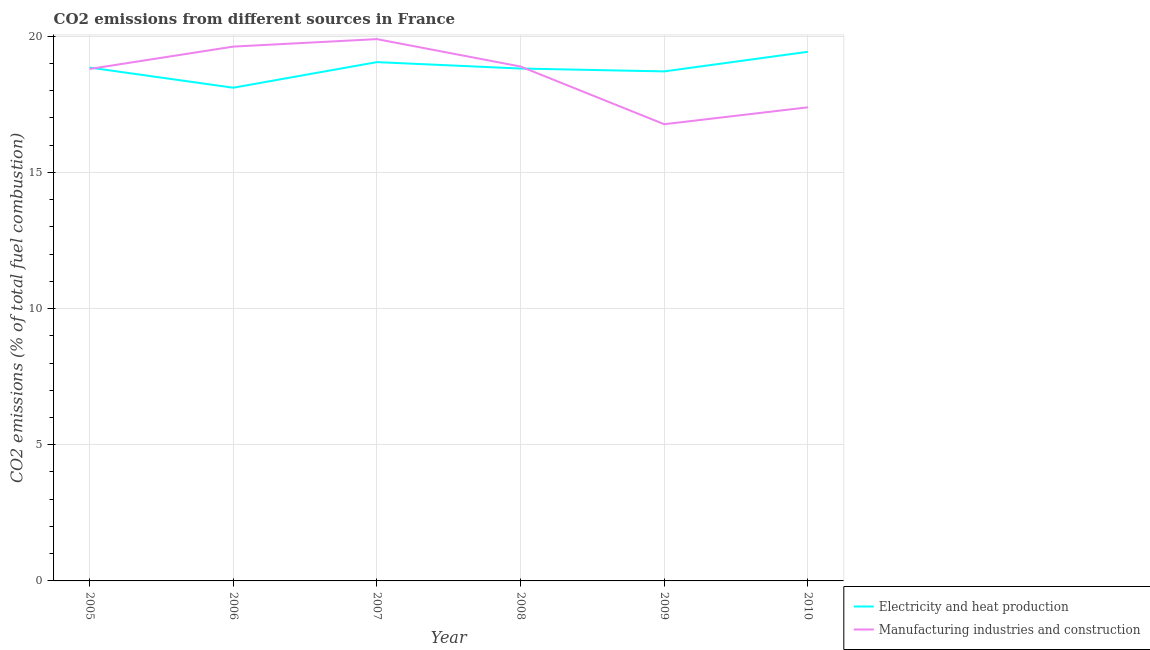Does the line corresponding to co2 emissions due to electricity and heat production intersect with the line corresponding to co2 emissions due to manufacturing industries?
Your answer should be compact. Yes. Is the number of lines equal to the number of legend labels?
Offer a terse response. Yes. What is the co2 emissions due to electricity and heat production in 2010?
Keep it short and to the point. 19.43. Across all years, what is the maximum co2 emissions due to manufacturing industries?
Your answer should be compact. 19.89. Across all years, what is the minimum co2 emissions due to electricity and heat production?
Make the answer very short. 18.11. In which year was the co2 emissions due to manufacturing industries maximum?
Ensure brevity in your answer.  2007. What is the total co2 emissions due to manufacturing industries in the graph?
Your response must be concise. 111.37. What is the difference between the co2 emissions due to manufacturing industries in 2005 and that in 2008?
Your answer should be very brief. -0.09. What is the difference between the co2 emissions due to manufacturing industries in 2006 and the co2 emissions due to electricity and heat production in 2005?
Keep it short and to the point. 0.77. What is the average co2 emissions due to manufacturing industries per year?
Provide a short and direct response. 18.56. In the year 2008, what is the difference between the co2 emissions due to electricity and heat production and co2 emissions due to manufacturing industries?
Your answer should be compact. -0.07. In how many years, is the co2 emissions due to electricity and heat production greater than 7 %?
Provide a short and direct response. 6. What is the ratio of the co2 emissions due to electricity and heat production in 2007 to that in 2009?
Offer a very short reply. 1.02. Is the co2 emissions due to electricity and heat production in 2007 less than that in 2008?
Your answer should be compact. No. Is the difference between the co2 emissions due to electricity and heat production in 2006 and 2008 greater than the difference between the co2 emissions due to manufacturing industries in 2006 and 2008?
Ensure brevity in your answer.  No. What is the difference between the highest and the second highest co2 emissions due to electricity and heat production?
Your answer should be very brief. 0.38. What is the difference between the highest and the lowest co2 emissions due to manufacturing industries?
Give a very brief answer. 3.12. Is the sum of the co2 emissions due to manufacturing industries in 2007 and 2009 greater than the maximum co2 emissions due to electricity and heat production across all years?
Give a very brief answer. Yes. Does the co2 emissions due to manufacturing industries monotonically increase over the years?
Offer a terse response. No. Is the co2 emissions due to manufacturing industries strictly less than the co2 emissions due to electricity and heat production over the years?
Give a very brief answer. No. How many years are there in the graph?
Offer a terse response. 6. What is the difference between two consecutive major ticks on the Y-axis?
Ensure brevity in your answer.  5. Are the values on the major ticks of Y-axis written in scientific E-notation?
Provide a succinct answer. No. How are the legend labels stacked?
Make the answer very short. Vertical. What is the title of the graph?
Give a very brief answer. CO2 emissions from different sources in France. What is the label or title of the X-axis?
Your answer should be compact. Year. What is the label or title of the Y-axis?
Offer a terse response. CO2 emissions (% of total fuel combustion). What is the CO2 emissions (% of total fuel combustion) in Electricity and heat production in 2005?
Ensure brevity in your answer.  18.85. What is the CO2 emissions (% of total fuel combustion) in Manufacturing industries and construction in 2005?
Your answer should be very brief. 18.8. What is the CO2 emissions (% of total fuel combustion) of Electricity and heat production in 2006?
Your answer should be compact. 18.11. What is the CO2 emissions (% of total fuel combustion) of Manufacturing industries and construction in 2006?
Make the answer very short. 19.62. What is the CO2 emissions (% of total fuel combustion) in Electricity and heat production in 2007?
Your answer should be compact. 19.05. What is the CO2 emissions (% of total fuel combustion) in Manufacturing industries and construction in 2007?
Your answer should be compact. 19.89. What is the CO2 emissions (% of total fuel combustion) in Electricity and heat production in 2008?
Your answer should be compact. 18.82. What is the CO2 emissions (% of total fuel combustion) in Manufacturing industries and construction in 2008?
Offer a very short reply. 18.89. What is the CO2 emissions (% of total fuel combustion) of Electricity and heat production in 2009?
Your response must be concise. 18.71. What is the CO2 emissions (% of total fuel combustion) of Manufacturing industries and construction in 2009?
Keep it short and to the point. 16.77. What is the CO2 emissions (% of total fuel combustion) of Electricity and heat production in 2010?
Your response must be concise. 19.43. What is the CO2 emissions (% of total fuel combustion) of Manufacturing industries and construction in 2010?
Make the answer very short. 17.39. Across all years, what is the maximum CO2 emissions (% of total fuel combustion) in Electricity and heat production?
Make the answer very short. 19.43. Across all years, what is the maximum CO2 emissions (% of total fuel combustion) in Manufacturing industries and construction?
Offer a terse response. 19.89. Across all years, what is the minimum CO2 emissions (% of total fuel combustion) in Electricity and heat production?
Give a very brief answer. 18.11. Across all years, what is the minimum CO2 emissions (% of total fuel combustion) of Manufacturing industries and construction?
Your response must be concise. 16.77. What is the total CO2 emissions (% of total fuel combustion) of Electricity and heat production in the graph?
Make the answer very short. 112.97. What is the total CO2 emissions (% of total fuel combustion) of Manufacturing industries and construction in the graph?
Provide a short and direct response. 111.37. What is the difference between the CO2 emissions (% of total fuel combustion) in Electricity and heat production in 2005 and that in 2006?
Your answer should be very brief. 0.74. What is the difference between the CO2 emissions (% of total fuel combustion) in Manufacturing industries and construction in 2005 and that in 2006?
Provide a short and direct response. -0.82. What is the difference between the CO2 emissions (% of total fuel combustion) of Electricity and heat production in 2005 and that in 2007?
Offer a terse response. -0.2. What is the difference between the CO2 emissions (% of total fuel combustion) in Manufacturing industries and construction in 2005 and that in 2007?
Your answer should be very brief. -1.1. What is the difference between the CO2 emissions (% of total fuel combustion) in Electricity and heat production in 2005 and that in 2008?
Keep it short and to the point. 0.04. What is the difference between the CO2 emissions (% of total fuel combustion) of Manufacturing industries and construction in 2005 and that in 2008?
Your response must be concise. -0.09. What is the difference between the CO2 emissions (% of total fuel combustion) in Electricity and heat production in 2005 and that in 2009?
Keep it short and to the point. 0.14. What is the difference between the CO2 emissions (% of total fuel combustion) of Manufacturing industries and construction in 2005 and that in 2009?
Provide a short and direct response. 2.03. What is the difference between the CO2 emissions (% of total fuel combustion) of Electricity and heat production in 2005 and that in 2010?
Your answer should be compact. -0.58. What is the difference between the CO2 emissions (% of total fuel combustion) in Manufacturing industries and construction in 2005 and that in 2010?
Keep it short and to the point. 1.41. What is the difference between the CO2 emissions (% of total fuel combustion) in Electricity and heat production in 2006 and that in 2007?
Ensure brevity in your answer.  -0.94. What is the difference between the CO2 emissions (% of total fuel combustion) in Manufacturing industries and construction in 2006 and that in 2007?
Provide a succinct answer. -0.27. What is the difference between the CO2 emissions (% of total fuel combustion) in Electricity and heat production in 2006 and that in 2008?
Your answer should be compact. -0.7. What is the difference between the CO2 emissions (% of total fuel combustion) of Manufacturing industries and construction in 2006 and that in 2008?
Offer a terse response. 0.73. What is the difference between the CO2 emissions (% of total fuel combustion) of Electricity and heat production in 2006 and that in 2009?
Provide a succinct answer. -0.6. What is the difference between the CO2 emissions (% of total fuel combustion) in Manufacturing industries and construction in 2006 and that in 2009?
Provide a succinct answer. 2.85. What is the difference between the CO2 emissions (% of total fuel combustion) of Electricity and heat production in 2006 and that in 2010?
Offer a very short reply. -1.32. What is the difference between the CO2 emissions (% of total fuel combustion) in Manufacturing industries and construction in 2006 and that in 2010?
Give a very brief answer. 2.23. What is the difference between the CO2 emissions (% of total fuel combustion) of Electricity and heat production in 2007 and that in 2008?
Your response must be concise. 0.24. What is the difference between the CO2 emissions (% of total fuel combustion) of Manufacturing industries and construction in 2007 and that in 2008?
Provide a short and direct response. 1.01. What is the difference between the CO2 emissions (% of total fuel combustion) of Electricity and heat production in 2007 and that in 2009?
Your answer should be compact. 0.34. What is the difference between the CO2 emissions (% of total fuel combustion) in Manufacturing industries and construction in 2007 and that in 2009?
Your answer should be compact. 3.12. What is the difference between the CO2 emissions (% of total fuel combustion) in Electricity and heat production in 2007 and that in 2010?
Your response must be concise. -0.38. What is the difference between the CO2 emissions (% of total fuel combustion) of Manufacturing industries and construction in 2007 and that in 2010?
Your answer should be compact. 2.5. What is the difference between the CO2 emissions (% of total fuel combustion) of Electricity and heat production in 2008 and that in 2009?
Offer a terse response. 0.11. What is the difference between the CO2 emissions (% of total fuel combustion) in Manufacturing industries and construction in 2008 and that in 2009?
Offer a very short reply. 2.12. What is the difference between the CO2 emissions (% of total fuel combustion) of Electricity and heat production in 2008 and that in 2010?
Keep it short and to the point. -0.61. What is the difference between the CO2 emissions (% of total fuel combustion) of Manufacturing industries and construction in 2008 and that in 2010?
Your answer should be compact. 1.5. What is the difference between the CO2 emissions (% of total fuel combustion) in Electricity and heat production in 2009 and that in 2010?
Offer a terse response. -0.72. What is the difference between the CO2 emissions (% of total fuel combustion) of Manufacturing industries and construction in 2009 and that in 2010?
Ensure brevity in your answer.  -0.62. What is the difference between the CO2 emissions (% of total fuel combustion) of Electricity and heat production in 2005 and the CO2 emissions (% of total fuel combustion) of Manufacturing industries and construction in 2006?
Offer a terse response. -0.77. What is the difference between the CO2 emissions (% of total fuel combustion) of Electricity and heat production in 2005 and the CO2 emissions (% of total fuel combustion) of Manufacturing industries and construction in 2007?
Ensure brevity in your answer.  -1.04. What is the difference between the CO2 emissions (% of total fuel combustion) of Electricity and heat production in 2005 and the CO2 emissions (% of total fuel combustion) of Manufacturing industries and construction in 2008?
Your response must be concise. -0.04. What is the difference between the CO2 emissions (% of total fuel combustion) of Electricity and heat production in 2005 and the CO2 emissions (% of total fuel combustion) of Manufacturing industries and construction in 2009?
Provide a short and direct response. 2.08. What is the difference between the CO2 emissions (% of total fuel combustion) in Electricity and heat production in 2005 and the CO2 emissions (% of total fuel combustion) in Manufacturing industries and construction in 2010?
Your answer should be very brief. 1.46. What is the difference between the CO2 emissions (% of total fuel combustion) of Electricity and heat production in 2006 and the CO2 emissions (% of total fuel combustion) of Manufacturing industries and construction in 2007?
Ensure brevity in your answer.  -1.78. What is the difference between the CO2 emissions (% of total fuel combustion) of Electricity and heat production in 2006 and the CO2 emissions (% of total fuel combustion) of Manufacturing industries and construction in 2008?
Provide a succinct answer. -0.78. What is the difference between the CO2 emissions (% of total fuel combustion) in Electricity and heat production in 2006 and the CO2 emissions (% of total fuel combustion) in Manufacturing industries and construction in 2009?
Offer a very short reply. 1.34. What is the difference between the CO2 emissions (% of total fuel combustion) of Electricity and heat production in 2006 and the CO2 emissions (% of total fuel combustion) of Manufacturing industries and construction in 2010?
Your response must be concise. 0.72. What is the difference between the CO2 emissions (% of total fuel combustion) of Electricity and heat production in 2007 and the CO2 emissions (% of total fuel combustion) of Manufacturing industries and construction in 2008?
Offer a very short reply. 0.16. What is the difference between the CO2 emissions (% of total fuel combustion) of Electricity and heat production in 2007 and the CO2 emissions (% of total fuel combustion) of Manufacturing industries and construction in 2009?
Your answer should be compact. 2.28. What is the difference between the CO2 emissions (% of total fuel combustion) in Electricity and heat production in 2007 and the CO2 emissions (% of total fuel combustion) in Manufacturing industries and construction in 2010?
Keep it short and to the point. 1.66. What is the difference between the CO2 emissions (% of total fuel combustion) in Electricity and heat production in 2008 and the CO2 emissions (% of total fuel combustion) in Manufacturing industries and construction in 2009?
Your response must be concise. 2.04. What is the difference between the CO2 emissions (% of total fuel combustion) of Electricity and heat production in 2008 and the CO2 emissions (% of total fuel combustion) of Manufacturing industries and construction in 2010?
Your answer should be very brief. 1.42. What is the difference between the CO2 emissions (% of total fuel combustion) in Electricity and heat production in 2009 and the CO2 emissions (% of total fuel combustion) in Manufacturing industries and construction in 2010?
Provide a succinct answer. 1.32. What is the average CO2 emissions (% of total fuel combustion) in Electricity and heat production per year?
Provide a succinct answer. 18.83. What is the average CO2 emissions (% of total fuel combustion) in Manufacturing industries and construction per year?
Give a very brief answer. 18.56. In the year 2005, what is the difference between the CO2 emissions (% of total fuel combustion) of Electricity and heat production and CO2 emissions (% of total fuel combustion) of Manufacturing industries and construction?
Offer a terse response. 0.05. In the year 2006, what is the difference between the CO2 emissions (% of total fuel combustion) in Electricity and heat production and CO2 emissions (% of total fuel combustion) in Manufacturing industries and construction?
Ensure brevity in your answer.  -1.51. In the year 2007, what is the difference between the CO2 emissions (% of total fuel combustion) of Electricity and heat production and CO2 emissions (% of total fuel combustion) of Manufacturing industries and construction?
Provide a succinct answer. -0.84. In the year 2008, what is the difference between the CO2 emissions (% of total fuel combustion) in Electricity and heat production and CO2 emissions (% of total fuel combustion) in Manufacturing industries and construction?
Your answer should be very brief. -0.07. In the year 2009, what is the difference between the CO2 emissions (% of total fuel combustion) in Electricity and heat production and CO2 emissions (% of total fuel combustion) in Manufacturing industries and construction?
Keep it short and to the point. 1.94. In the year 2010, what is the difference between the CO2 emissions (% of total fuel combustion) in Electricity and heat production and CO2 emissions (% of total fuel combustion) in Manufacturing industries and construction?
Your answer should be compact. 2.04. What is the ratio of the CO2 emissions (% of total fuel combustion) of Electricity and heat production in 2005 to that in 2006?
Make the answer very short. 1.04. What is the ratio of the CO2 emissions (% of total fuel combustion) in Manufacturing industries and construction in 2005 to that in 2006?
Offer a very short reply. 0.96. What is the ratio of the CO2 emissions (% of total fuel combustion) in Electricity and heat production in 2005 to that in 2007?
Make the answer very short. 0.99. What is the ratio of the CO2 emissions (% of total fuel combustion) in Manufacturing industries and construction in 2005 to that in 2007?
Your answer should be very brief. 0.94. What is the ratio of the CO2 emissions (% of total fuel combustion) of Manufacturing industries and construction in 2005 to that in 2008?
Provide a short and direct response. 1. What is the ratio of the CO2 emissions (% of total fuel combustion) of Electricity and heat production in 2005 to that in 2009?
Provide a short and direct response. 1.01. What is the ratio of the CO2 emissions (% of total fuel combustion) in Manufacturing industries and construction in 2005 to that in 2009?
Make the answer very short. 1.12. What is the ratio of the CO2 emissions (% of total fuel combustion) in Electricity and heat production in 2005 to that in 2010?
Offer a terse response. 0.97. What is the ratio of the CO2 emissions (% of total fuel combustion) of Manufacturing industries and construction in 2005 to that in 2010?
Ensure brevity in your answer.  1.08. What is the ratio of the CO2 emissions (% of total fuel combustion) of Electricity and heat production in 2006 to that in 2007?
Make the answer very short. 0.95. What is the ratio of the CO2 emissions (% of total fuel combustion) of Manufacturing industries and construction in 2006 to that in 2007?
Keep it short and to the point. 0.99. What is the ratio of the CO2 emissions (% of total fuel combustion) of Electricity and heat production in 2006 to that in 2008?
Ensure brevity in your answer.  0.96. What is the ratio of the CO2 emissions (% of total fuel combustion) of Manufacturing industries and construction in 2006 to that in 2008?
Your response must be concise. 1.04. What is the ratio of the CO2 emissions (% of total fuel combustion) in Electricity and heat production in 2006 to that in 2009?
Your answer should be compact. 0.97. What is the ratio of the CO2 emissions (% of total fuel combustion) of Manufacturing industries and construction in 2006 to that in 2009?
Offer a terse response. 1.17. What is the ratio of the CO2 emissions (% of total fuel combustion) of Electricity and heat production in 2006 to that in 2010?
Provide a succinct answer. 0.93. What is the ratio of the CO2 emissions (% of total fuel combustion) in Manufacturing industries and construction in 2006 to that in 2010?
Your answer should be compact. 1.13. What is the ratio of the CO2 emissions (% of total fuel combustion) of Electricity and heat production in 2007 to that in 2008?
Offer a very short reply. 1.01. What is the ratio of the CO2 emissions (% of total fuel combustion) in Manufacturing industries and construction in 2007 to that in 2008?
Make the answer very short. 1.05. What is the ratio of the CO2 emissions (% of total fuel combustion) of Electricity and heat production in 2007 to that in 2009?
Ensure brevity in your answer.  1.02. What is the ratio of the CO2 emissions (% of total fuel combustion) in Manufacturing industries and construction in 2007 to that in 2009?
Provide a short and direct response. 1.19. What is the ratio of the CO2 emissions (% of total fuel combustion) of Electricity and heat production in 2007 to that in 2010?
Provide a short and direct response. 0.98. What is the ratio of the CO2 emissions (% of total fuel combustion) of Manufacturing industries and construction in 2007 to that in 2010?
Your answer should be compact. 1.14. What is the ratio of the CO2 emissions (% of total fuel combustion) of Electricity and heat production in 2008 to that in 2009?
Provide a short and direct response. 1.01. What is the ratio of the CO2 emissions (% of total fuel combustion) of Manufacturing industries and construction in 2008 to that in 2009?
Give a very brief answer. 1.13. What is the ratio of the CO2 emissions (% of total fuel combustion) in Electricity and heat production in 2008 to that in 2010?
Your answer should be compact. 0.97. What is the ratio of the CO2 emissions (% of total fuel combustion) in Manufacturing industries and construction in 2008 to that in 2010?
Provide a succinct answer. 1.09. What is the ratio of the CO2 emissions (% of total fuel combustion) of Electricity and heat production in 2009 to that in 2010?
Ensure brevity in your answer.  0.96. What is the difference between the highest and the second highest CO2 emissions (% of total fuel combustion) of Electricity and heat production?
Ensure brevity in your answer.  0.38. What is the difference between the highest and the second highest CO2 emissions (% of total fuel combustion) of Manufacturing industries and construction?
Your response must be concise. 0.27. What is the difference between the highest and the lowest CO2 emissions (% of total fuel combustion) of Electricity and heat production?
Your answer should be compact. 1.32. What is the difference between the highest and the lowest CO2 emissions (% of total fuel combustion) of Manufacturing industries and construction?
Ensure brevity in your answer.  3.12. 